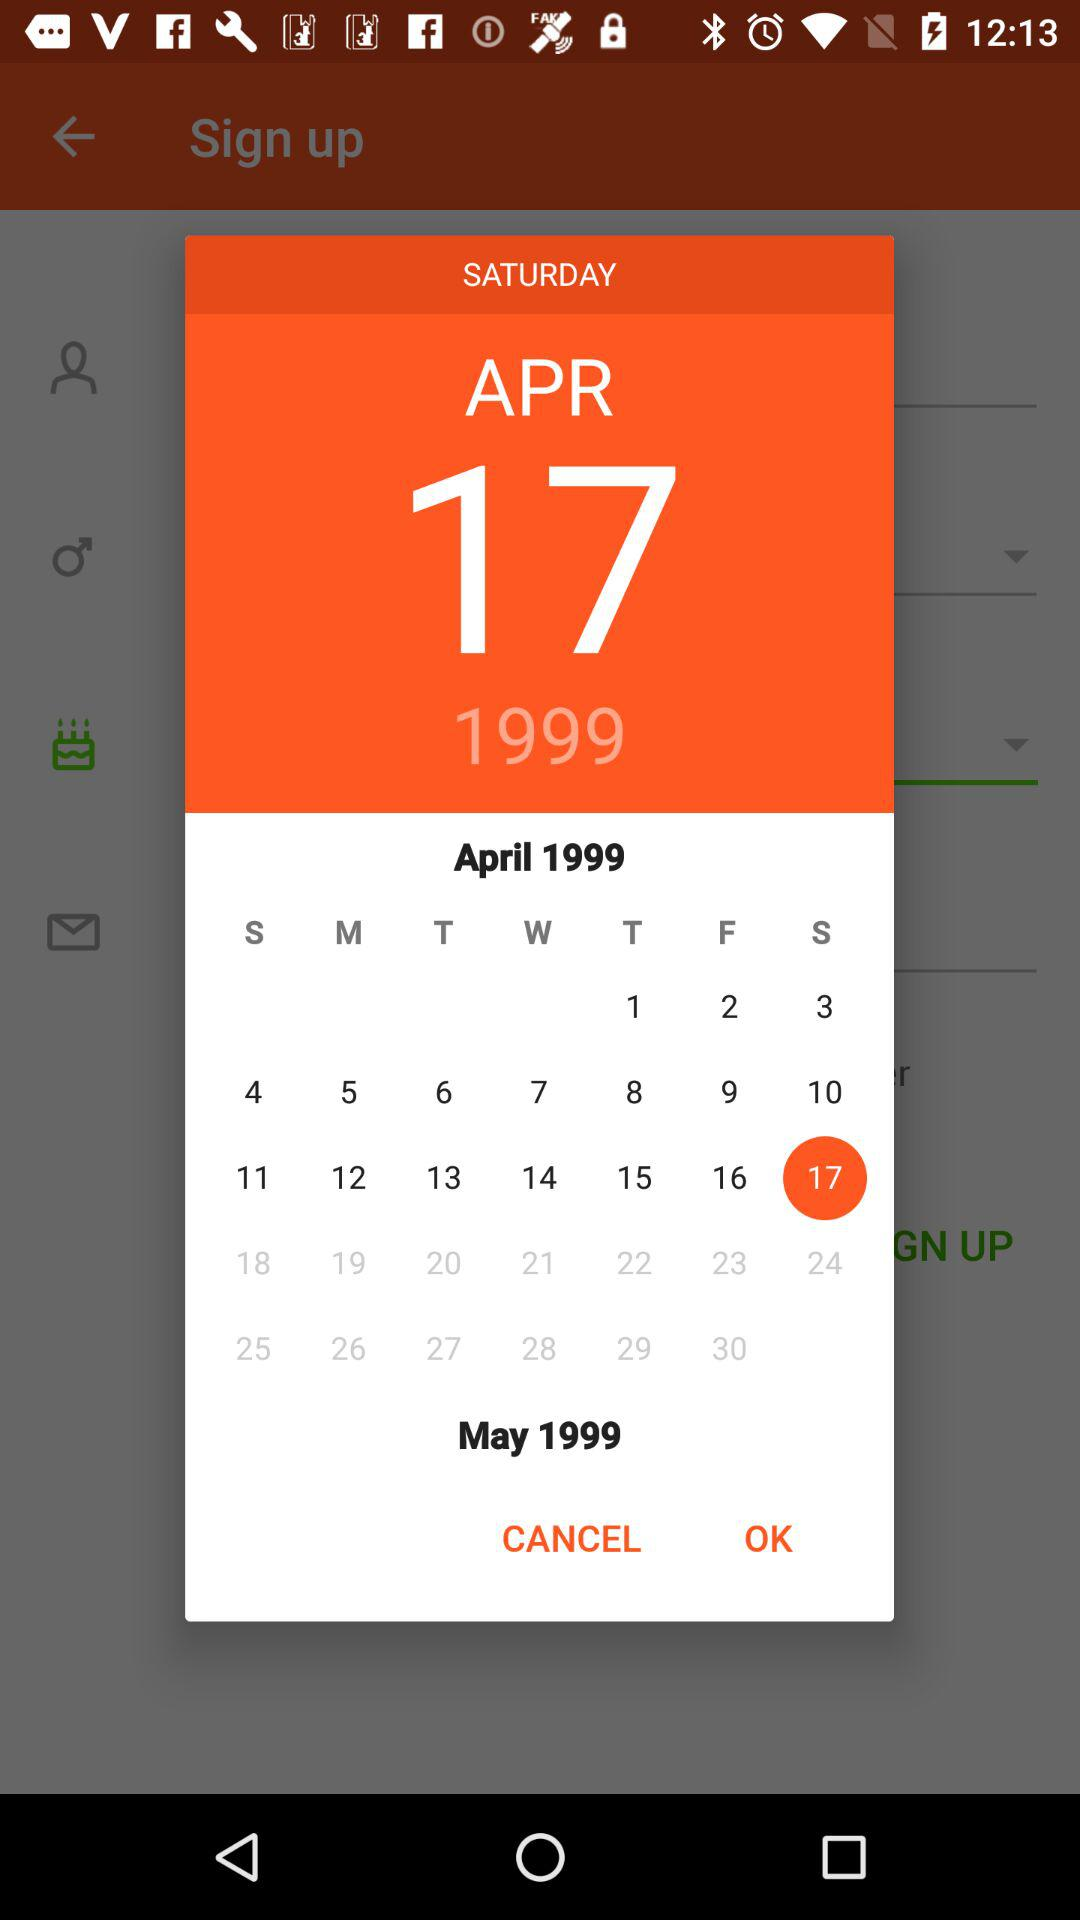Which year has been chosen? The chosen year is 1999. 